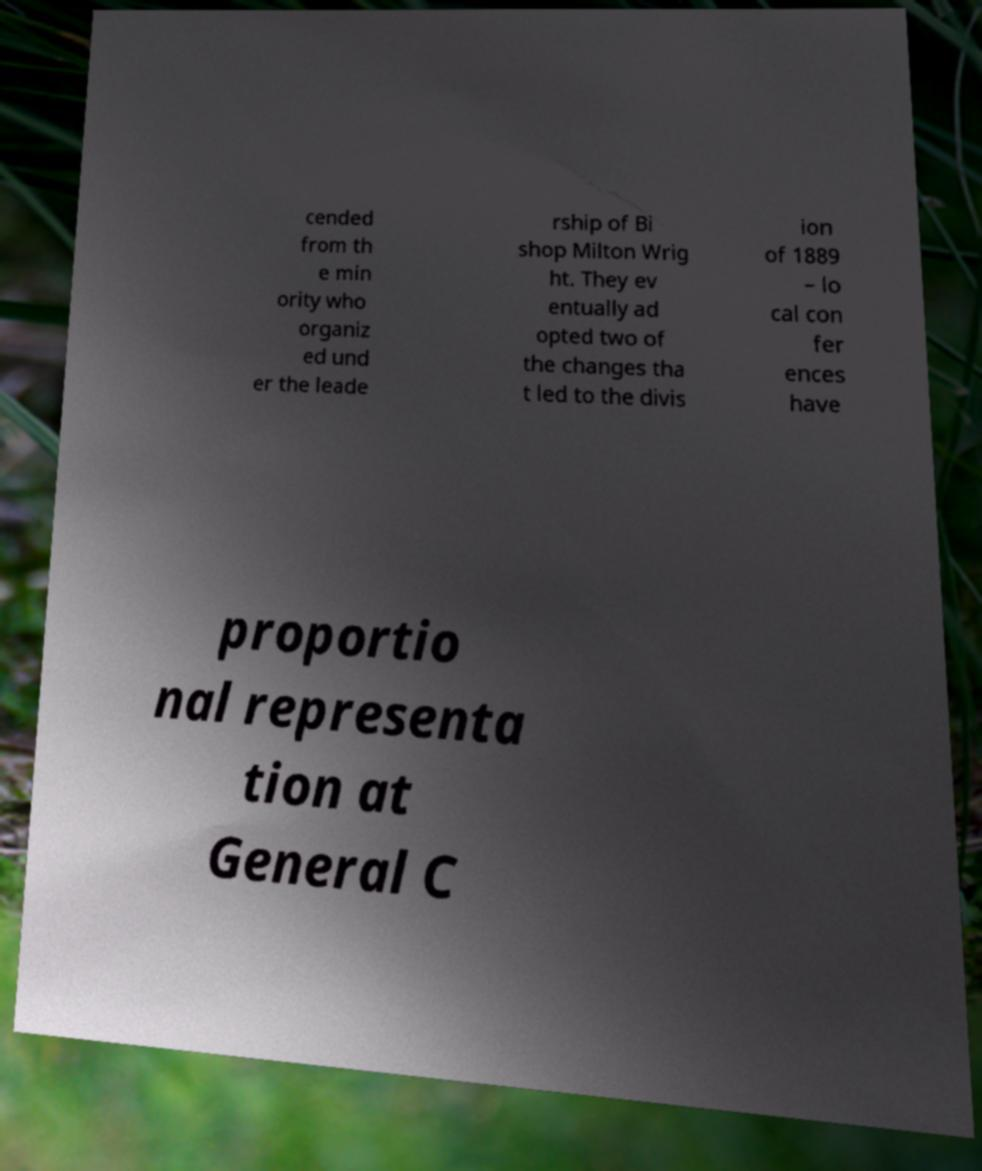Please identify and transcribe the text found in this image. cended from th e min ority who organiz ed und er the leade rship of Bi shop Milton Wrig ht. They ev entually ad opted two of the changes tha t led to the divis ion of 1889 – lo cal con fer ences have proportio nal representa tion at General C 